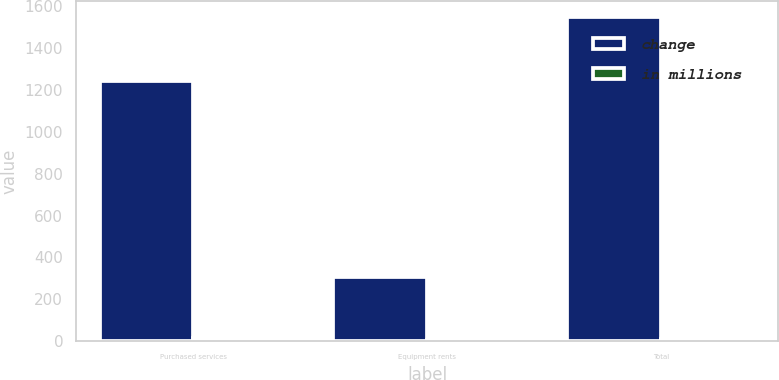Convert chart. <chart><loc_0><loc_0><loc_500><loc_500><stacked_bar_chart><ecel><fcel>Purchased services<fcel>Equipment rents<fcel>Total<nl><fcel>change<fcel>1242<fcel>306<fcel>1548<nl><fcel>in millions<fcel>13<fcel>4<fcel>12<nl></chart> 